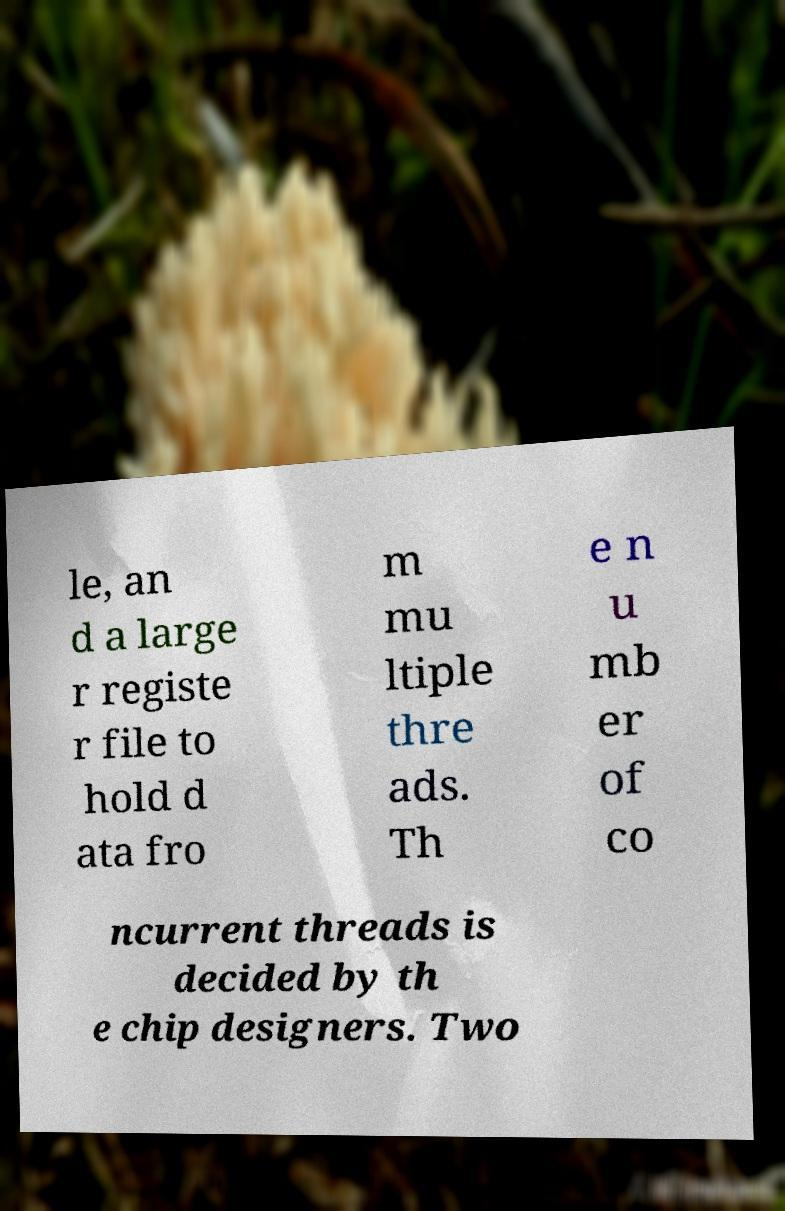There's text embedded in this image that I need extracted. Can you transcribe it verbatim? le, an d a large r registe r file to hold d ata fro m mu ltiple thre ads. Th e n u mb er of co ncurrent threads is decided by th e chip designers. Two 